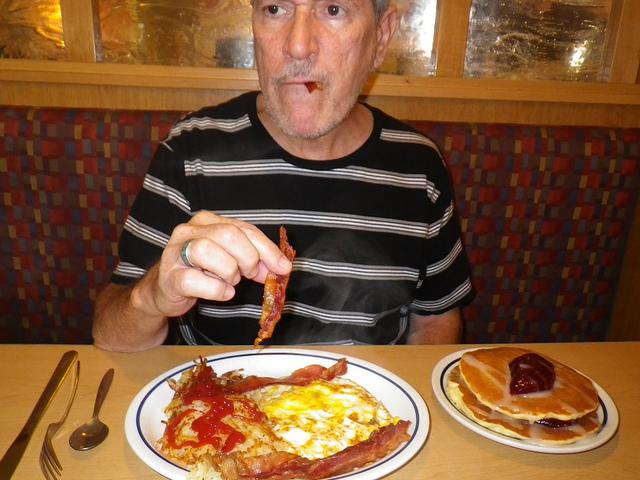Where is he eating?
Answer briefly. Restaurant. Is this a restaurant?
Answer briefly. Yes. What currency was used to purchase this meal?
Concise answer only. Dollars. Does this food come in a box?
Quick response, please. No. Is this an Asian restaurant?
Answer briefly. No. Is the man using his hand to eat?
Give a very brief answer. Yes. What is the food?
Be succinct. Breakfast. What kind of food is this?
Keep it brief. Breakfast. How many forks are there?
Keep it brief. 1. What is in the picture?
Quick response, please. Breakfast. What is the serving?
Concise answer only. Breakfast. Is this a party?
Quick response, please. No. What is the person doing with their right fingers?
Give a very brief answer. Holding bacon. Are the walls dirty behind the man?
Quick response, please. No. How would you describe the pattern of the fabric on the chairs?
Answer briefly. Squares. Does he have beer?
Quick response, please. No. What types of food are in the photo?
Concise answer only. Breakfast. What is he eating?
Quick response, please. Bacon. What is the man holding?
Concise answer only. Bacon. What is the man eating in the hand?
Keep it brief. Bacon. What is this person eating?
Concise answer only. Bacon. What is the man eating?
Answer briefly. Bacon. Are these pancakes?
Write a very short answer. Yes. 